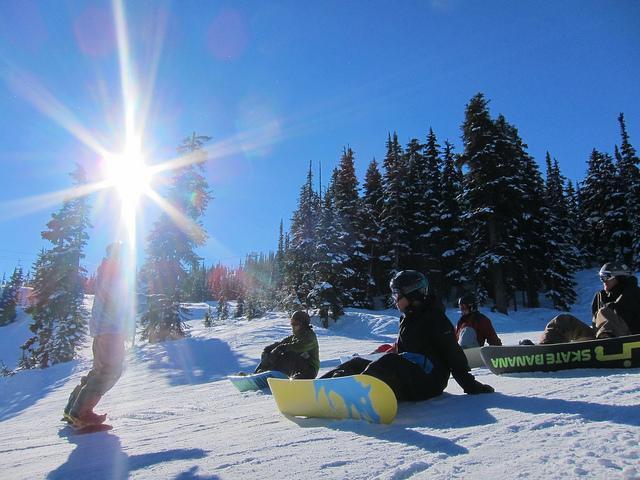How many people are in the picture?
Give a very brief answer. 4. How many snowboards can be seen?
Give a very brief answer. 2. 